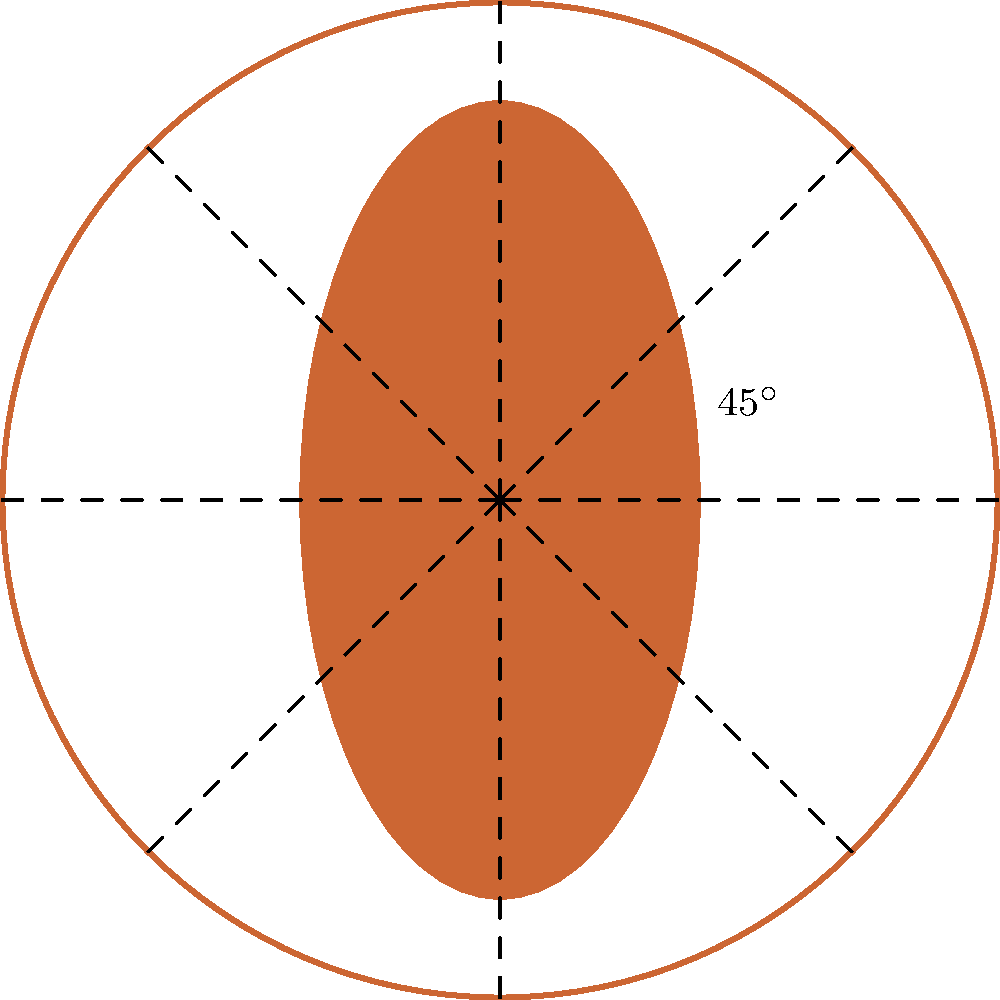Consider the circular quilling pattern shown above, which consists of 8 identical petal-shaped elements arranged symmetrically around a central point. What is the order of the rotational symmetry group for this pattern, and what is the smallest non-zero angle of rotation that leaves the pattern unchanged? To determine the order of the rotational symmetry group and the smallest non-zero angle of rotation, we need to follow these steps:

1. Observe the pattern:
   The quilling design shows 8 identical petal-shaped elements arranged in a circular pattern.

2. Identify rotational symmetries:
   The pattern remains unchanged when rotated by certain angles around its center.

3. Calculate the smallest rotation angle:
   The smallest rotation that leaves the pattern unchanged is a $45^\circ$ rotation (as indicated in the diagram).
   This is because: $360^\circ \div 8 = 45^\circ$

4. Determine all possible rotations:
   The pattern will look the same after rotations of:
   $45^\circ, 90^\circ, 135^\circ, 180^\circ, 225^\circ, 270^\circ, 315^\circ$, and $360^\circ$ (which is equivalent to $0^\circ$)

5. Count the number of distinct rotations:
   There are 8 distinct rotations (including the identity rotation of $0^\circ$) that leave the pattern unchanged.

6. Identify the order of the rotational symmetry group:
   The order of the group is equal to the number of distinct rotations, which is 8.

Therefore, the order of the rotational symmetry group is 8, and the smallest non-zero angle of rotation that leaves the pattern unchanged is $45^\circ$.
Answer: Order: 8, Smallest angle: $45^\circ$ 